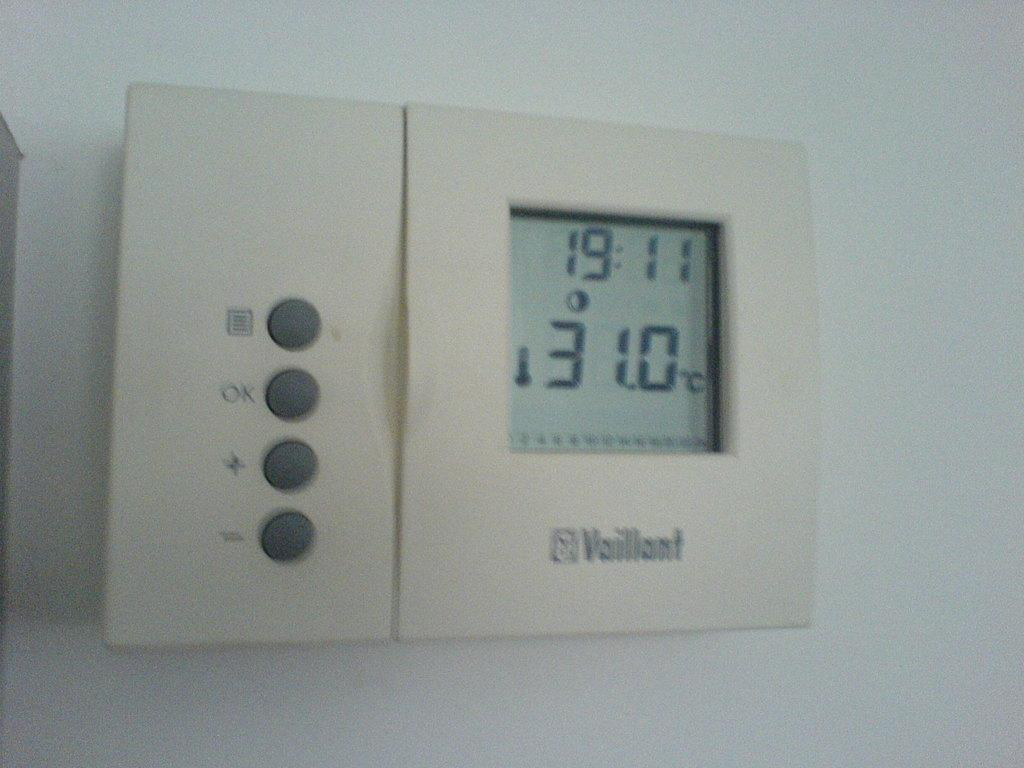<image>
Offer a succinct explanation of the picture presented. A tan Vaillant thermostat with the setting of 31.0 degrees celsius on it. 